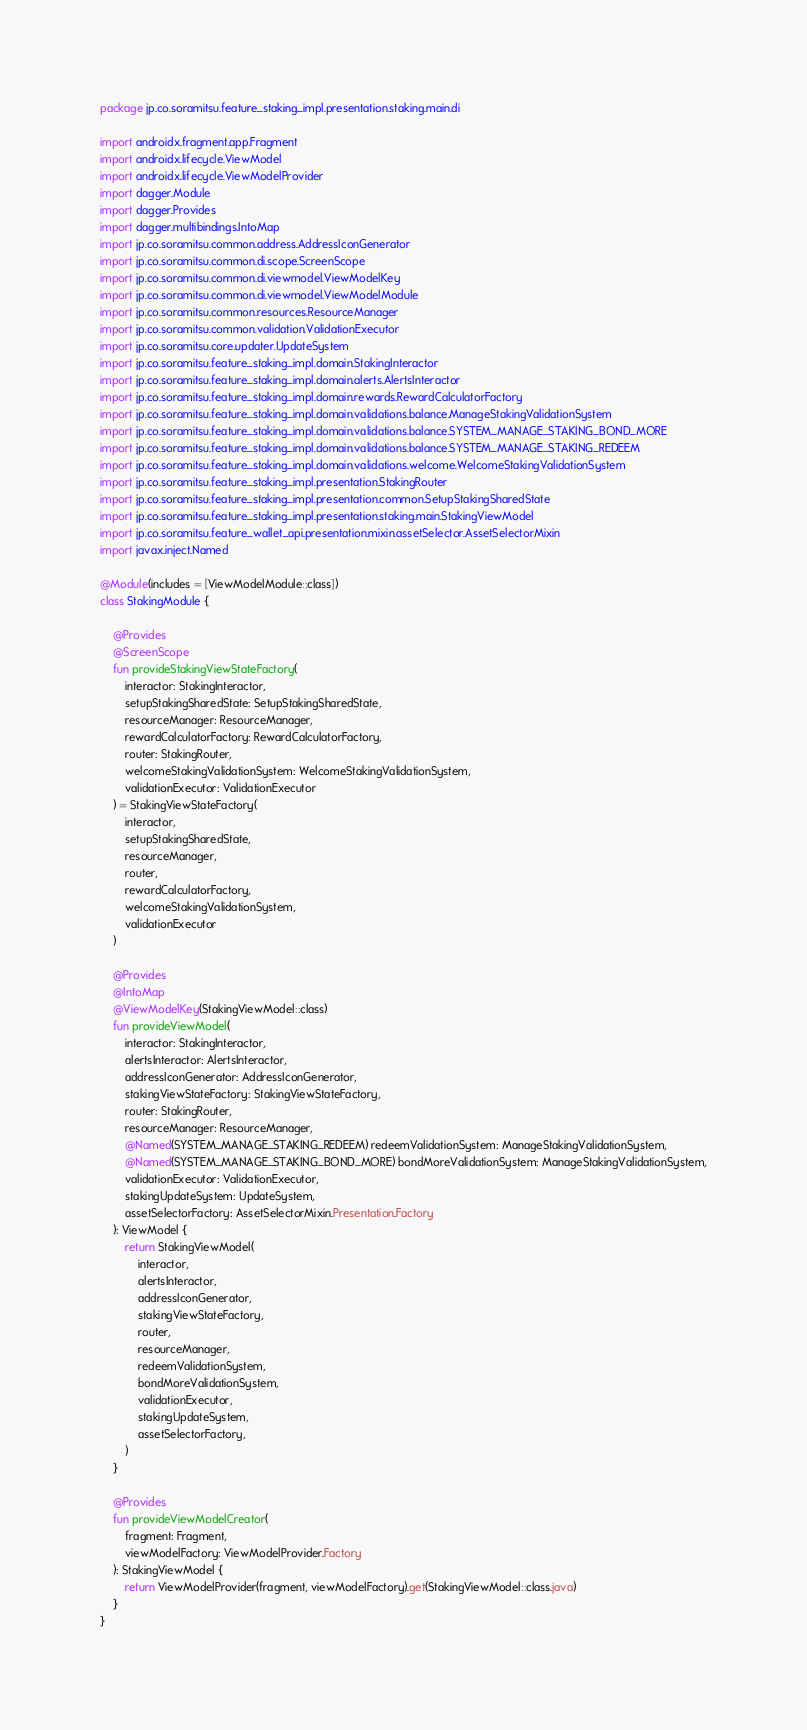<code> <loc_0><loc_0><loc_500><loc_500><_Kotlin_>package jp.co.soramitsu.feature_staking_impl.presentation.staking.main.di

import androidx.fragment.app.Fragment
import androidx.lifecycle.ViewModel
import androidx.lifecycle.ViewModelProvider
import dagger.Module
import dagger.Provides
import dagger.multibindings.IntoMap
import jp.co.soramitsu.common.address.AddressIconGenerator
import jp.co.soramitsu.common.di.scope.ScreenScope
import jp.co.soramitsu.common.di.viewmodel.ViewModelKey
import jp.co.soramitsu.common.di.viewmodel.ViewModelModule
import jp.co.soramitsu.common.resources.ResourceManager
import jp.co.soramitsu.common.validation.ValidationExecutor
import jp.co.soramitsu.core.updater.UpdateSystem
import jp.co.soramitsu.feature_staking_impl.domain.StakingInteractor
import jp.co.soramitsu.feature_staking_impl.domain.alerts.AlertsInteractor
import jp.co.soramitsu.feature_staking_impl.domain.rewards.RewardCalculatorFactory
import jp.co.soramitsu.feature_staking_impl.domain.validations.balance.ManageStakingValidationSystem
import jp.co.soramitsu.feature_staking_impl.domain.validations.balance.SYSTEM_MANAGE_STAKING_BOND_MORE
import jp.co.soramitsu.feature_staking_impl.domain.validations.balance.SYSTEM_MANAGE_STAKING_REDEEM
import jp.co.soramitsu.feature_staking_impl.domain.validations.welcome.WelcomeStakingValidationSystem
import jp.co.soramitsu.feature_staking_impl.presentation.StakingRouter
import jp.co.soramitsu.feature_staking_impl.presentation.common.SetupStakingSharedState
import jp.co.soramitsu.feature_staking_impl.presentation.staking.main.StakingViewModel
import jp.co.soramitsu.feature_wallet_api.presentation.mixin.assetSelector.AssetSelectorMixin
import javax.inject.Named

@Module(includes = [ViewModelModule::class])
class StakingModule {

    @Provides
    @ScreenScope
    fun provideStakingViewStateFactory(
        interactor: StakingInteractor,
        setupStakingSharedState: SetupStakingSharedState,
        resourceManager: ResourceManager,
        rewardCalculatorFactory: RewardCalculatorFactory,
        router: StakingRouter,
        welcomeStakingValidationSystem: WelcomeStakingValidationSystem,
        validationExecutor: ValidationExecutor
    ) = StakingViewStateFactory(
        interactor,
        setupStakingSharedState,
        resourceManager,
        router,
        rewardCalculatorFactory,
        welcomeStakingValidationSystem,
        validationExecutor
    )

    @Provides
    @IntoMap
    @ViewModelKey(StakingViewModel::class)
    fun provideViewModel(
        interactor: StakingInteractor,
        alertsInteractor: AlertsInteractor,
        addressIconGenerator: AddressIconGenerator,
        stakingViewStateFactory: StakingViewStateFactory,
        router: StakingRouter,
        resourceManager: ResourceManager,
        @Named(SYSTEM_MANAGE_STAKING_REDEEM) redeemValidationSystem: ManageStakingValidationSystem,
        @Named(SYSTEM_MANAGE_STAKING_BOND_MORE) bondMoreValidationSystem: ManageStakingValidationSystem,
        validationExecutor: ValidationExecutor,
        stakingUpdateSystem: UpdateSystem,
        assetSelectorFactory: AssetSelectorMixin.Presentation.Factory
    ): ViewModel {
        return StakingViewModel(
            interactor,
            alertsInteractor,
            addressIconGenerator,
            stakingViewStateFactory,
            router,
            resourceManager,
            redeemValidationSystem,
            bondMoreValidationSystem,
            validationExecutor,
            stakingUpdateSystem,
            assetSelectorFactory,
        )
    }

    @Provides
    fun provideViewModelCreator(
        fragment: Fragment,
        viewModelFactory: ViewModelProvider.Factory
    ): StakingViewModel {
        return ViewModelProvider(fragment, viewModelFactory).get(StakingViewModel::class.java)
    }
}
</code> 